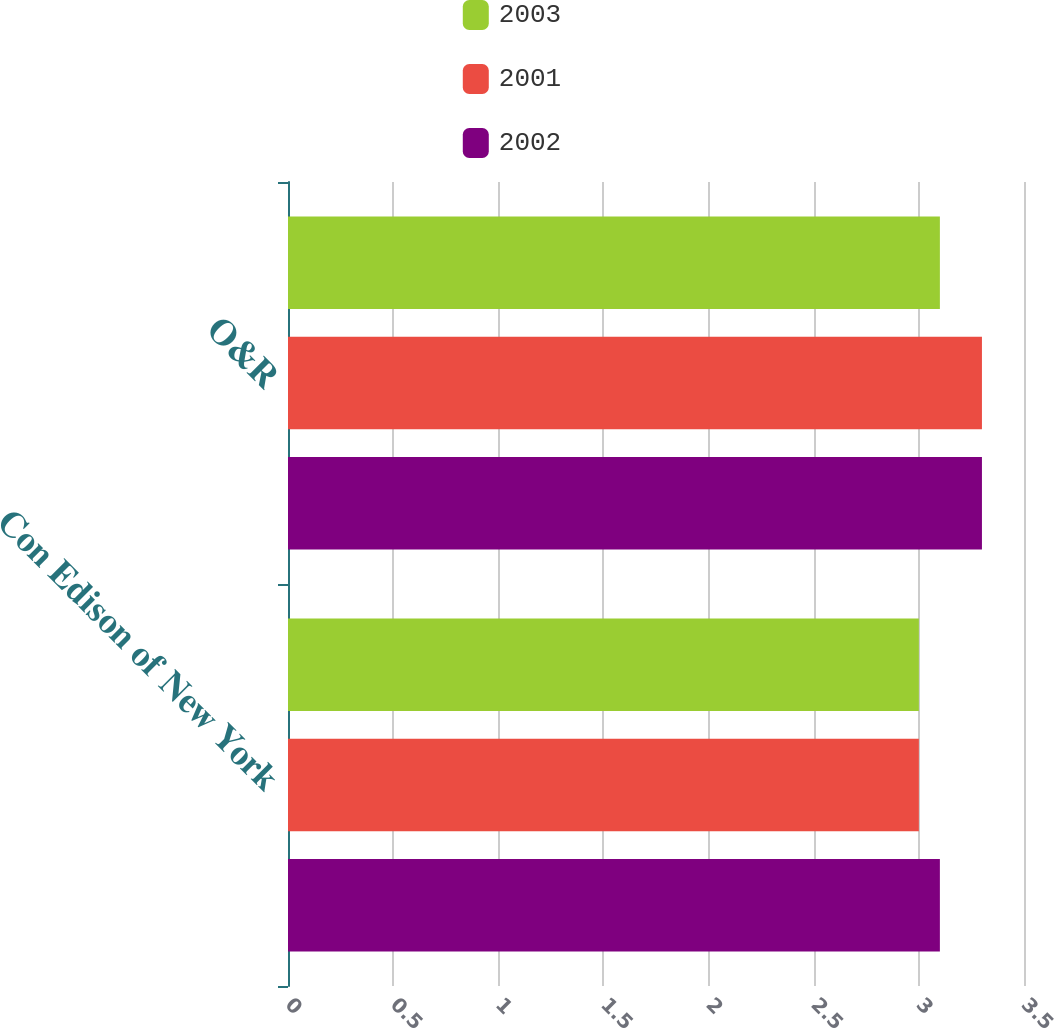<chart> <loc_0><loc_0><loc_500><loc_500><stacked_bar_chart><ecel><fcel>Con Edison of New York<fcel>O&R<nl><fcel>2003<fcel>3<fcel>3.1<nl><fcel>2001<fcel>3<fcel>3.3<nl><fcel>2002<fcel>3.1<fcel>3.3<nl></chart> 